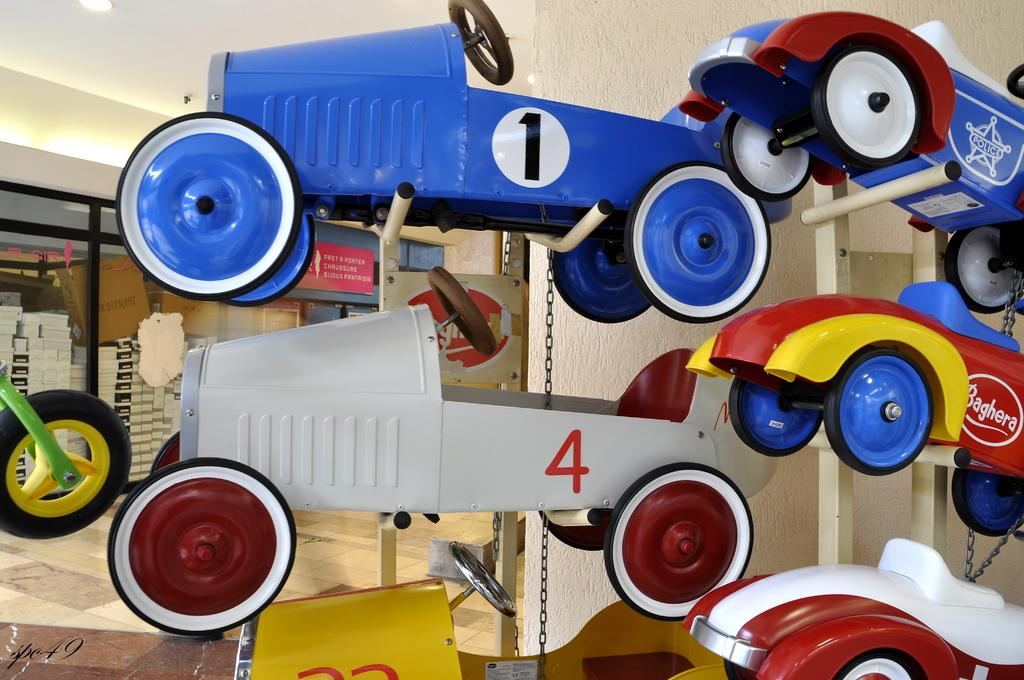What type of toys are on stands in the image? There are toy cars on stands in the image. What can be seen beside the glass wall in the image? There are boxes beside the glass wall in the image. What can be used for illumination in the image? There are lights visible in the image. What type of objects have text written on them in the image? There are boards with text in the image. Can you see a tiger walking near the toy cars in the image? No, there is no tiger present in the image. Is there a secretary working at a desk in the image? There is no desk or secretary present in the image. 